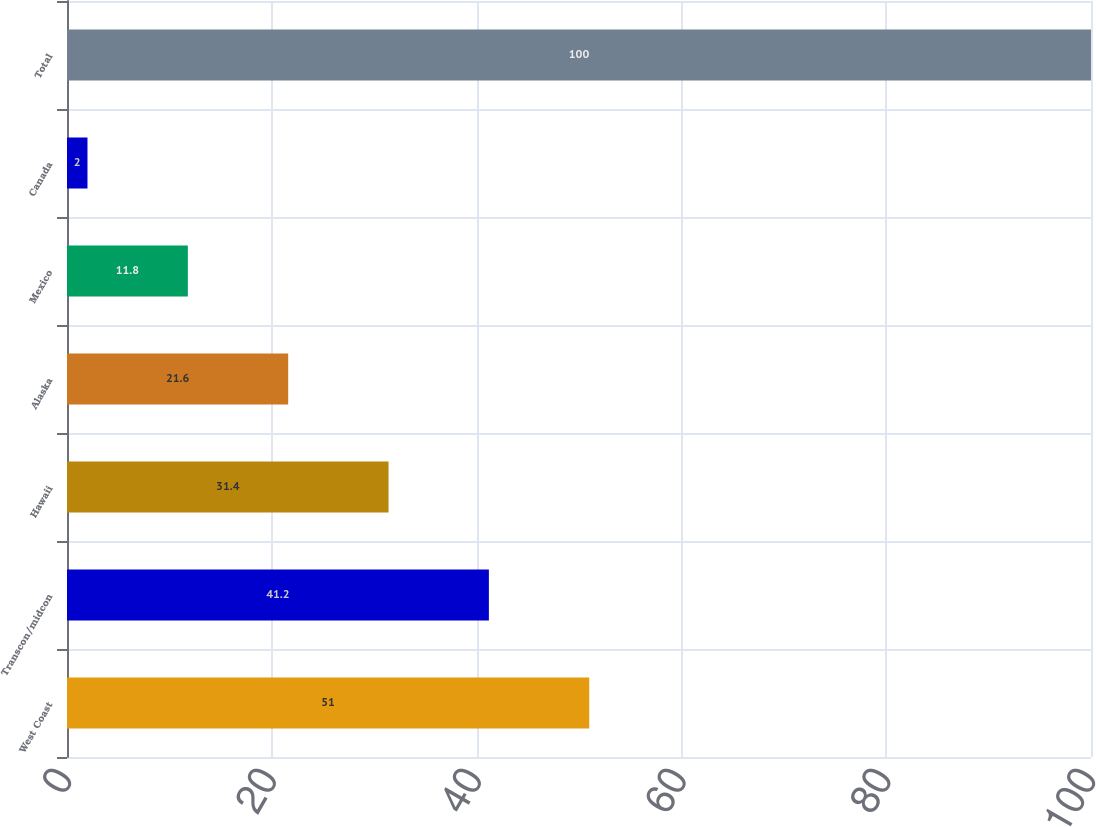Convert chart. <chart><loc_0><loc_0><loc_500><loc_500><bar_chart><fcel>West Coast<fcel>Transcon/midcon<fcel>Hawaii<fcel>Alaska<fcel>Mexico<fcel>Canada<fcel>Total<nl><fcel>51<fcel>41.2<fcel>31.4<fcel>21.6<fcel>11.8<fcel>2<fcel>100<nl></chart> 